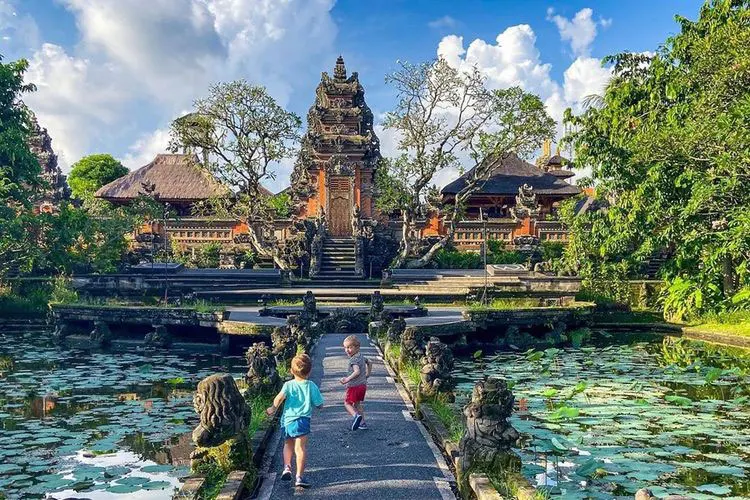Can you imagine a magical event happening here? Imagine an enchanting night at the Ubud Water Palace, where the statues and carvings come to life under the glow of a full moon. Guardians and mythical creatures would roam the gardens, interacting with visitors in a harmonious blend of history and fantasy. The pond would sparkle with bioluminescent lily pads, and the air would be filled with the scent of exotic flowers. Traditional Balinese music would play softly, guiding visitors on a magical journey through the palace's storied past. This event would be a celebration of culture and imagination, where the palace's beauty takes on an otherworldly dimension. What kind of festivals might be celebrated at the Ubud Water Palace? The Ubud Water Palace could host various festivals that celebrate Balinese culture and heritage. One such event could be the 'Festival of Lights,' where the entire palace and surrounding gardens are illuminated with traditional lanterns, creating a mesmerizing spectacle. Cultural performances, including traditional dances, music, and theatrical reenactments of ancient folktales, could take place, immersing visitors in the island's rich traditions. Another festival could be the 'Lily Pad Festival,' dedicated to the serene beauty of the pond. Activities might include guided botanical tours, children's treasure hunts, and serene yoga sessions on lily pad-themed platforms. These festivals would not only honor the palace's history but also create new memories for future generations. Imagine two mythical creatures having a conversation here, what would they talk about? Imagine a wise dragon and a mystical phoenix perched by the pond, sharing tales of ancient times. The dragon, with its deep, resonant voice, might recount stories of the palace's construction, the purpose of its architectural designs, and the legends of the artisans who created the intricate carvings. The phoenix, with a voice like a melodious song, might share stories of the palace's resilience, recounting how it has withstood the passage of centuries, the natural elements, and the changing world around it. They would discuss the harmony between the man-made and the natural, marveling at how the palace remains a sanctuary of peace and beauty in an ever-evolving world. 